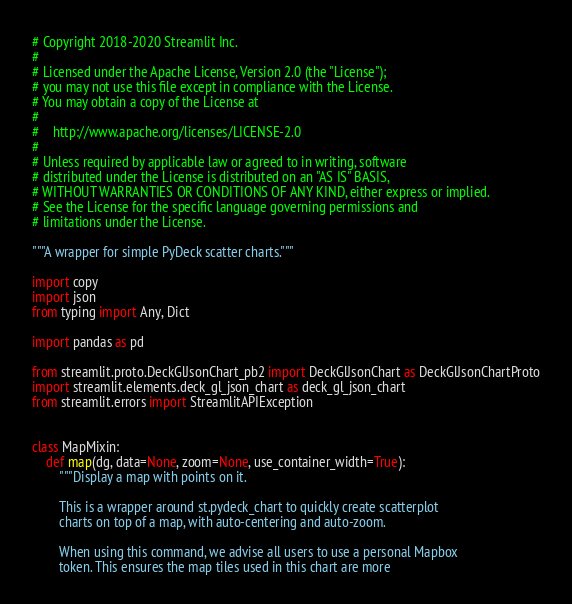Convert code to text. <code><loc_0><loc_0><loc_500><loc_500><_Python_># Copyright 2018-2020 Streamlit Inc.
#
# Licensed under the Apache License, Version 2.0 (the "License");
# you may not use this file except in compliance with the License.
# You may obtain a copy of the License at
#
#    http://www.apache.org/licenses/LICENSE-2.0
#
# Unless required by applicable law or agreed to in writing, software
# distributed under the License is distributed on an "AS IS" BASIS,
# WITHOUT WARRANTIES OR CONDITIONS OF ANY KIND, either express or implied.
# See the License for the specific language governing permissions and
# limitations under the License.

"""A wrapper for simple PyDeck scatter charts."""

import copy
import json
from typing import Any, Dict

import pandas as pd

from streamlit.proto.DeckGlJsonChart_pb2 import DeckGlJsonChart as DeckGlJsonChartProto
import streamlit.elements.deck_gl_json_chart as deck_gl_json_chart
from streamlit.errors import StreamlitAPIException


class MapMixin:
    def map(dg, data=None, zoom=None, use_container_width=True):
        """Display a map with points on it.

        This is a wrapper around st.pydeck_chart to quickly create scatterplot
        charts on top of a map, with auto-centering and auto-zoom.

        When using this command, we advise all users to use a personal Mapbox
        token. This ensures the map tiles used in this chart are more</code> 